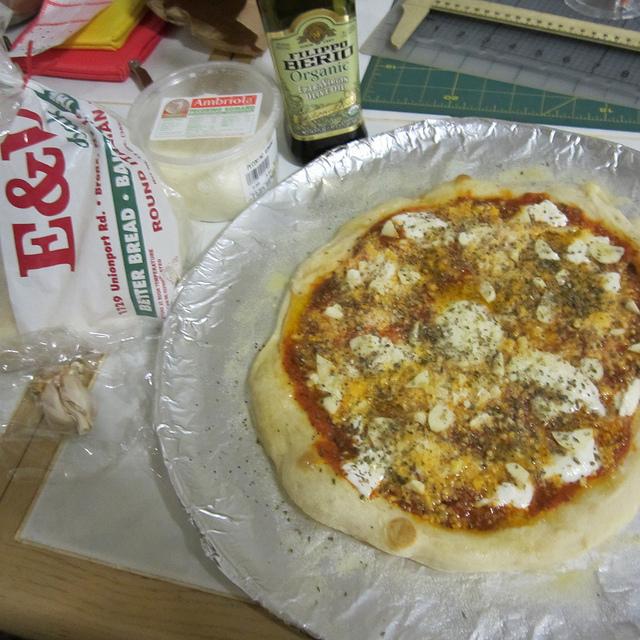What is this food?
Short answer required. Pizza. What is in the bottle?
Write a very short answer. Olive oil. Where is a measuring tool?
Quick response, please. Behind pizza. 